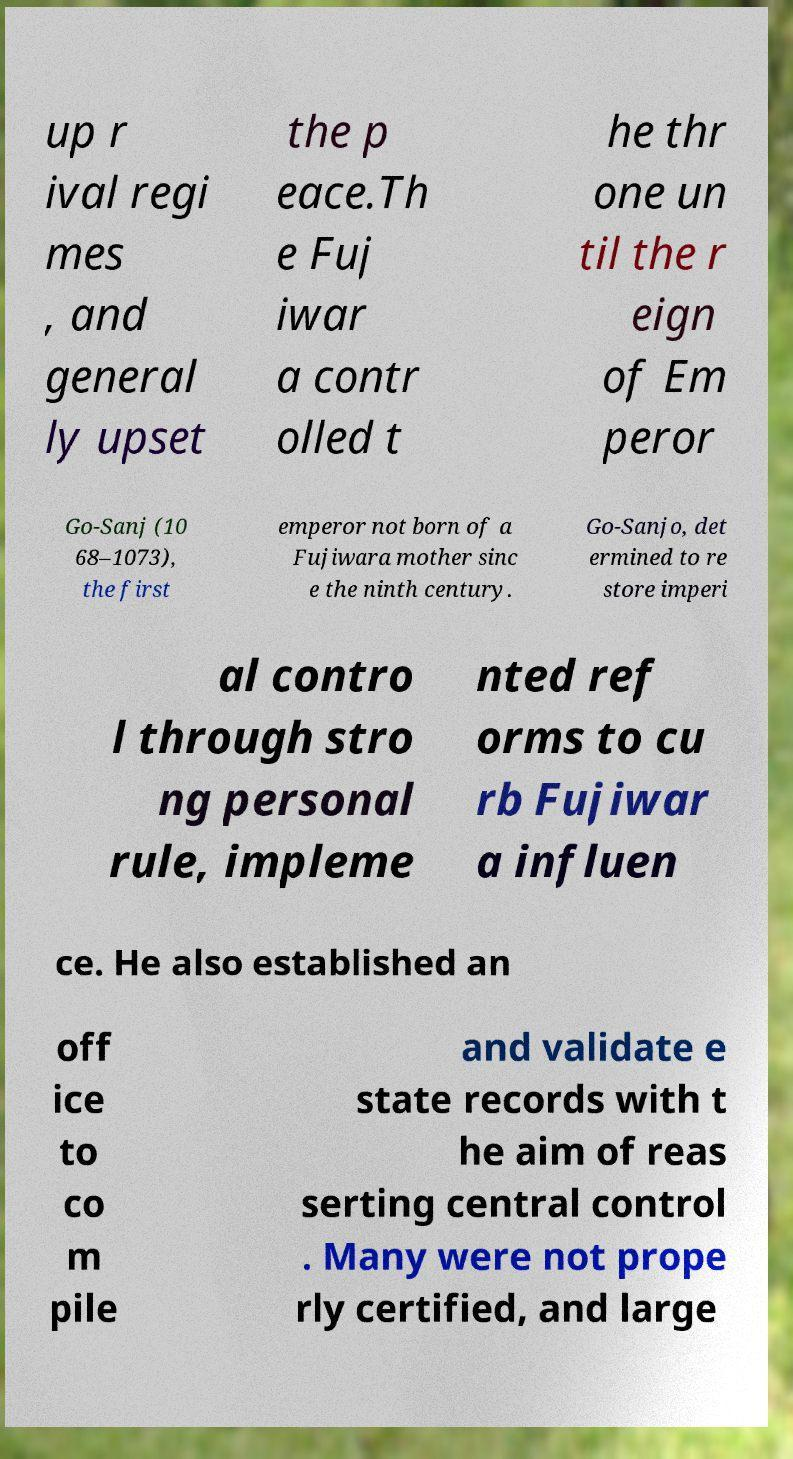Please identify and transcribe the text found in this image. up r ival regi mes , and general ly upset the p eace.Th e Fuj iwar a contr olled t he thr one un til the r eign of Em peror Go-Sanj (10 68–1073), the first emperor not born of a Fujiwara mother sinc e the ninth century. Go-Sanjo, det ermined to re store imperi al contro l through stro ng personal rule, impleme nted ref orms to cu rb Fujiwar a influen ce. He also established an off ice to co m pile and validate e state records with t he aim of reas serting central control . Many were not prope rly certified, and large 